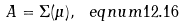<formula> <loc_0><loc_0><loc_500><loc_500>A = \Sigma ( \mu ) , \ e q n u m { 1 2 . 1 6 }</formula> 